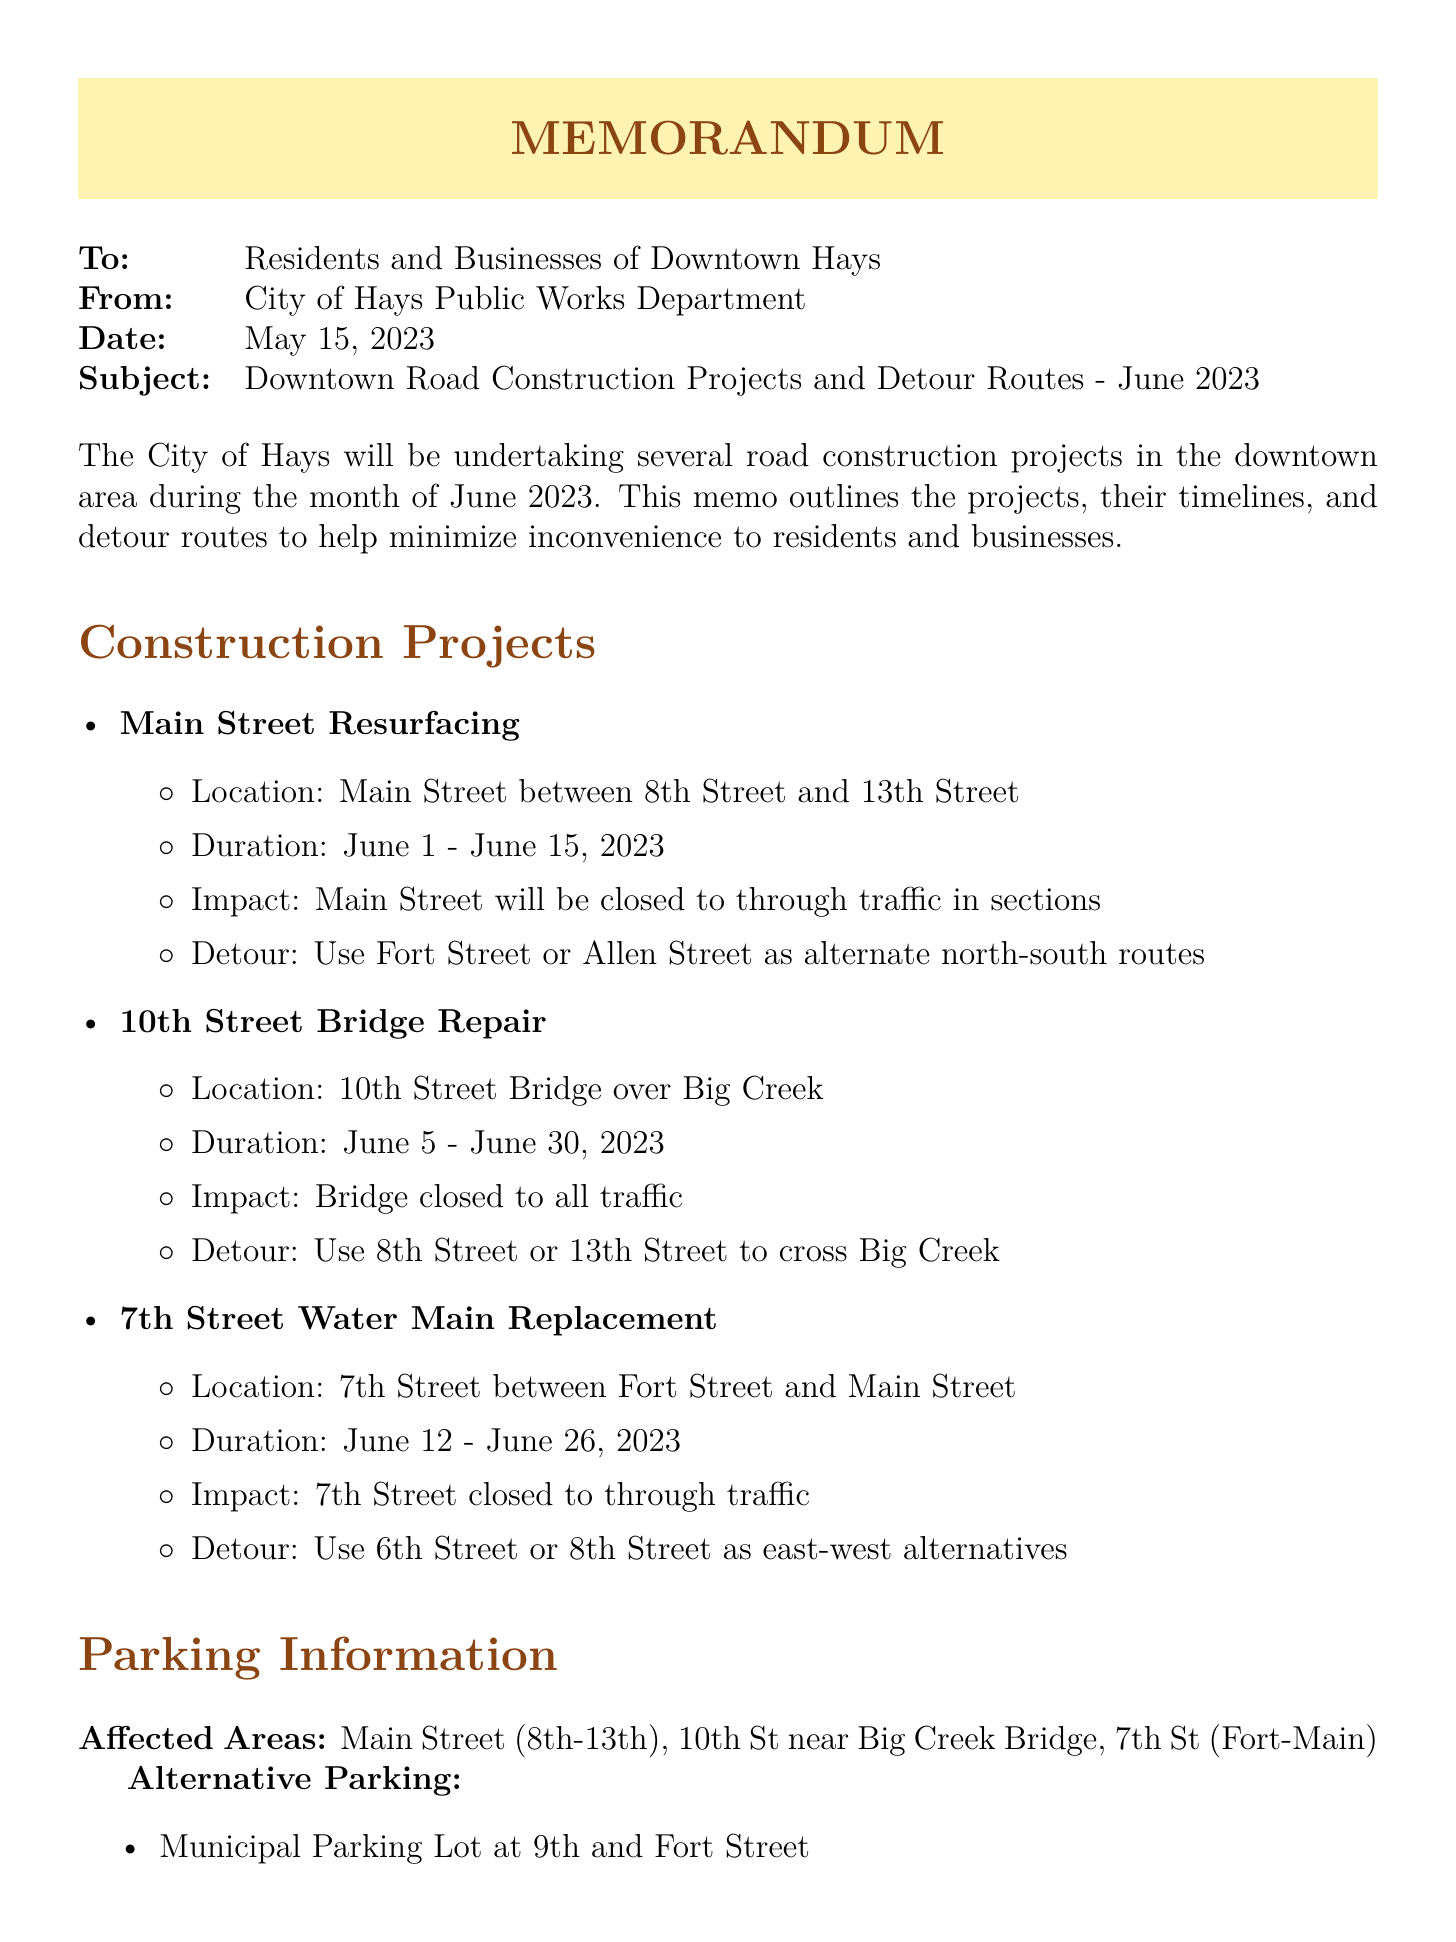what is the subject of the memo? The subject of the memo is specifically stated in the header, providing a clear focus on what the memo is about.
Answer: Downtown Road Construction Projects and Detour Routes - June 2023 who is the memo addressed to? The memo addresses the residents and businesses specifically located in the downtown area, indicating who the relevant audience is.
Answer: Residents and Businesses of Downtown Hays when does the Main Street Resurfacing project start? The start date for the Main Street Resurfacing project is mentioned in the project section of the document.
Answer: June 1, 2023 what is the alternative route for the 10th Street Bridge Repair? The document specifies the alternative routes for crossing Big Creek while the bridge is closed, providing a clear detour option.
Answer: Use 8th Street or 13th Street how long will the 7th Street Water Main Replacement last? The duration of the 7th Street Water Main Replacement project is provided in the project details section of the document.
Answer: June 12 - June 26, 2023 is public access to businesses affected during construction? The memo mentions the status of access to local businesses, indicating how they will be impacted by the roadwork.
Answer: No which public transportation service is affected? The memo lists the specific public transportation routes that will be impacted by the construction, indicating which services are affected.
Answer: ACCESS paratransit service and Hays City Route bus service where can residents find alternative parking? Alternative parking locations are provided in the parking information section, indicating options available to residents.
Answer: Municipal Parking Lot at 9th and Fort Street, Downtown Parking Garage on 11th Street, Street parking on adjacent unaffected streets 